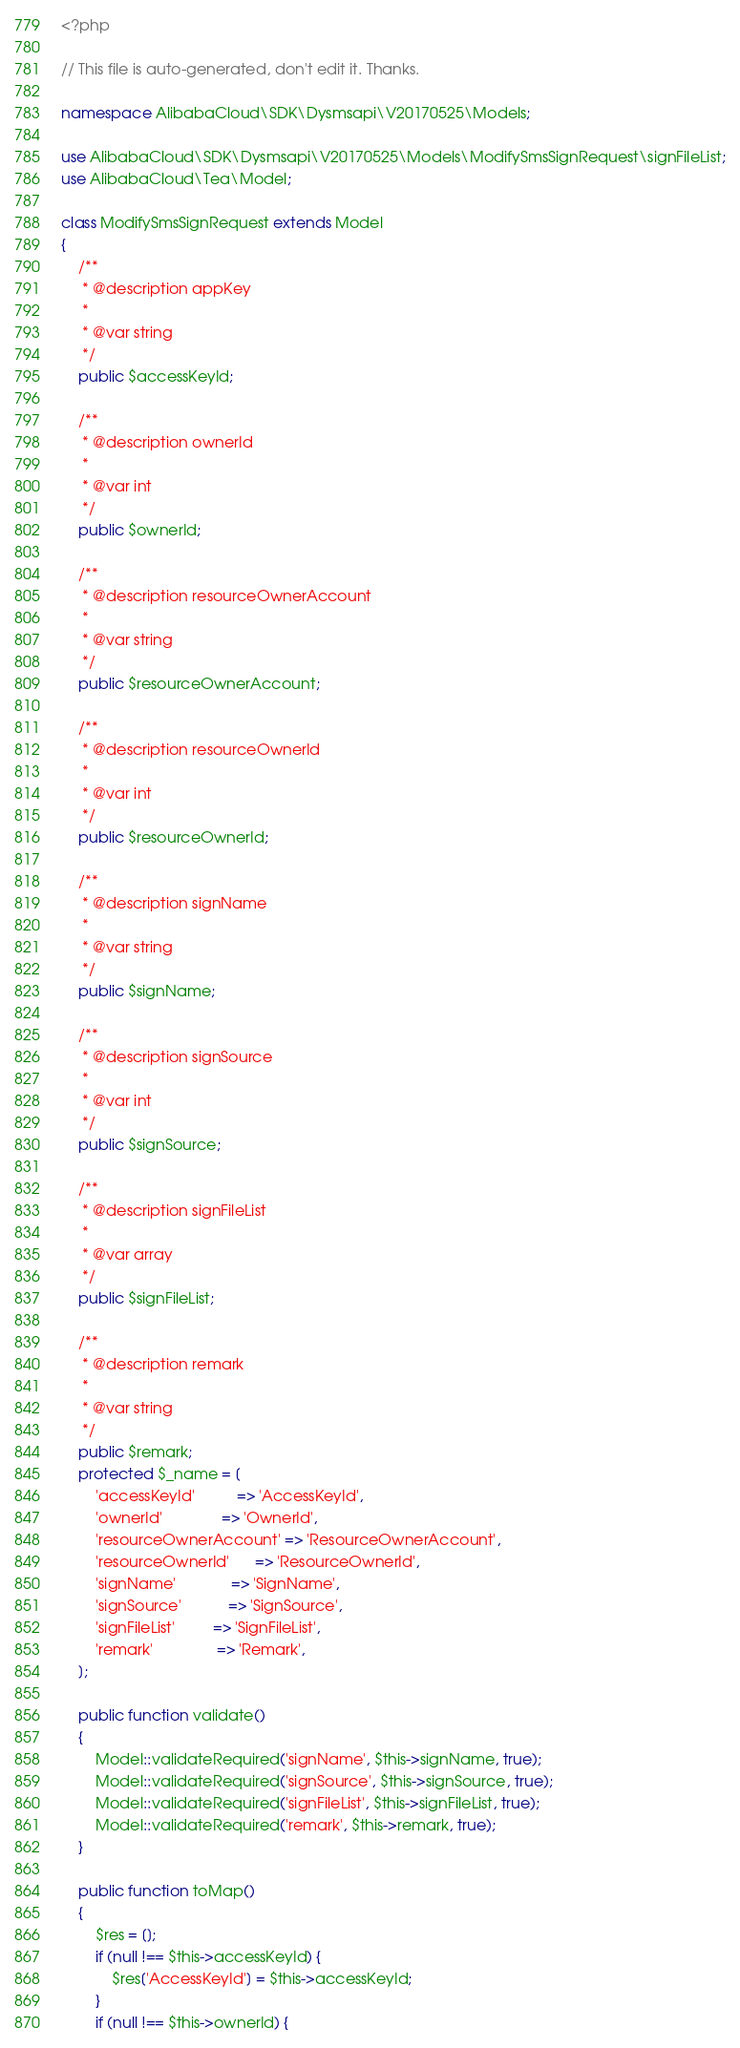Convert code to text. <code><loc_0><loc_0><loc_500><loc_500><_PHP_><?php

// This file is auto-generated, don't edit it. Thanks.

namespace AlibabaCloud\SDK\Dysmsapi\V20170525\Models;

use AlibabaCloud\SDK\Dysmsapi\V20170525\Models\ModifySmsSignRequest\signFileList;
use AlibabaCloud\Tea\Model;

class ModifySmsSignRequest extends Model
{
    /**
     * @description appKey
     *
     * @var string
     */
    public $accessKeyId;

    /**
     * @description ownerId
     *
     * @var int
     */
    public $ownerId;

    /**
     * @description resourceOwnerAccount
     *
     * @var string
     */
    public $resourceOwnerAccount;

    /**
     * @description resourceOwnerId
     *
     * @var int
     */
    public $resourceOwnerId;

    /**
     * @description signName
     *
     * @var string
     */
    public $signName;

    /**
     * @description signSource
     *
     * @var int
     */
    public $signSource;

    /**
     * @description signFileList
     *
     * @var array
     */
    public $signFileList;

    /**
     * @description remark
     *
     * @var string
     */
    public $remark;
    protected $_name = [
        'accessKeyId'          => 'AccessKeyId',
        'ownerId'              => 'OwnerId',
        'resourceOwnerAccount' => 'ResourceOwnerAccount',
        'resourceOwnerId'      => 'ResourceOwnerId',
        'signName'             => 'SignName',
        'signSource'           => 'SignSource',
        'signFileList'         => 'SignFileList',
        'remark'               => 'Remark',
    ];

    public function validate()
    {
        Model::validateRequired('signName', $this->signName, true);
        Model::validateRequired('signSource', $this->signSource, true);
        Model::validateRequired('signFileList', $this->signFileList, true);
        Model::validateRequired('remark', $this->remark, true);
    }

    public function toMap()
    {
        $res = [];
        if (null !== $this->accessKeyId) {
            $res['AccessKeyId'] = $this->accessKeyId;
        }
        if (null !== $this->ownerId) {</code> 